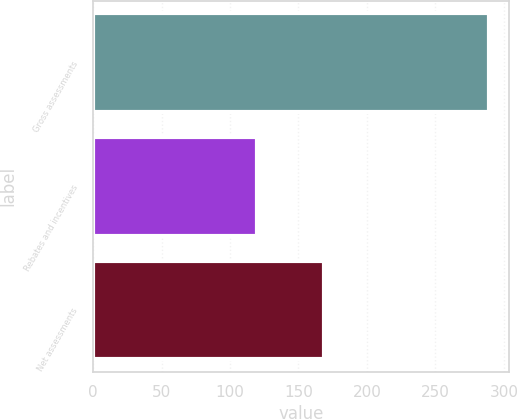<chart> <loc_0><loc_0><loc_500><loc_500><bar_chart><fcel>Gross assessments<fcel>Rebates and incentives<fcel>Net assessments<nl><fcel>289<fcel>120<fcel>169<nl></chart> 